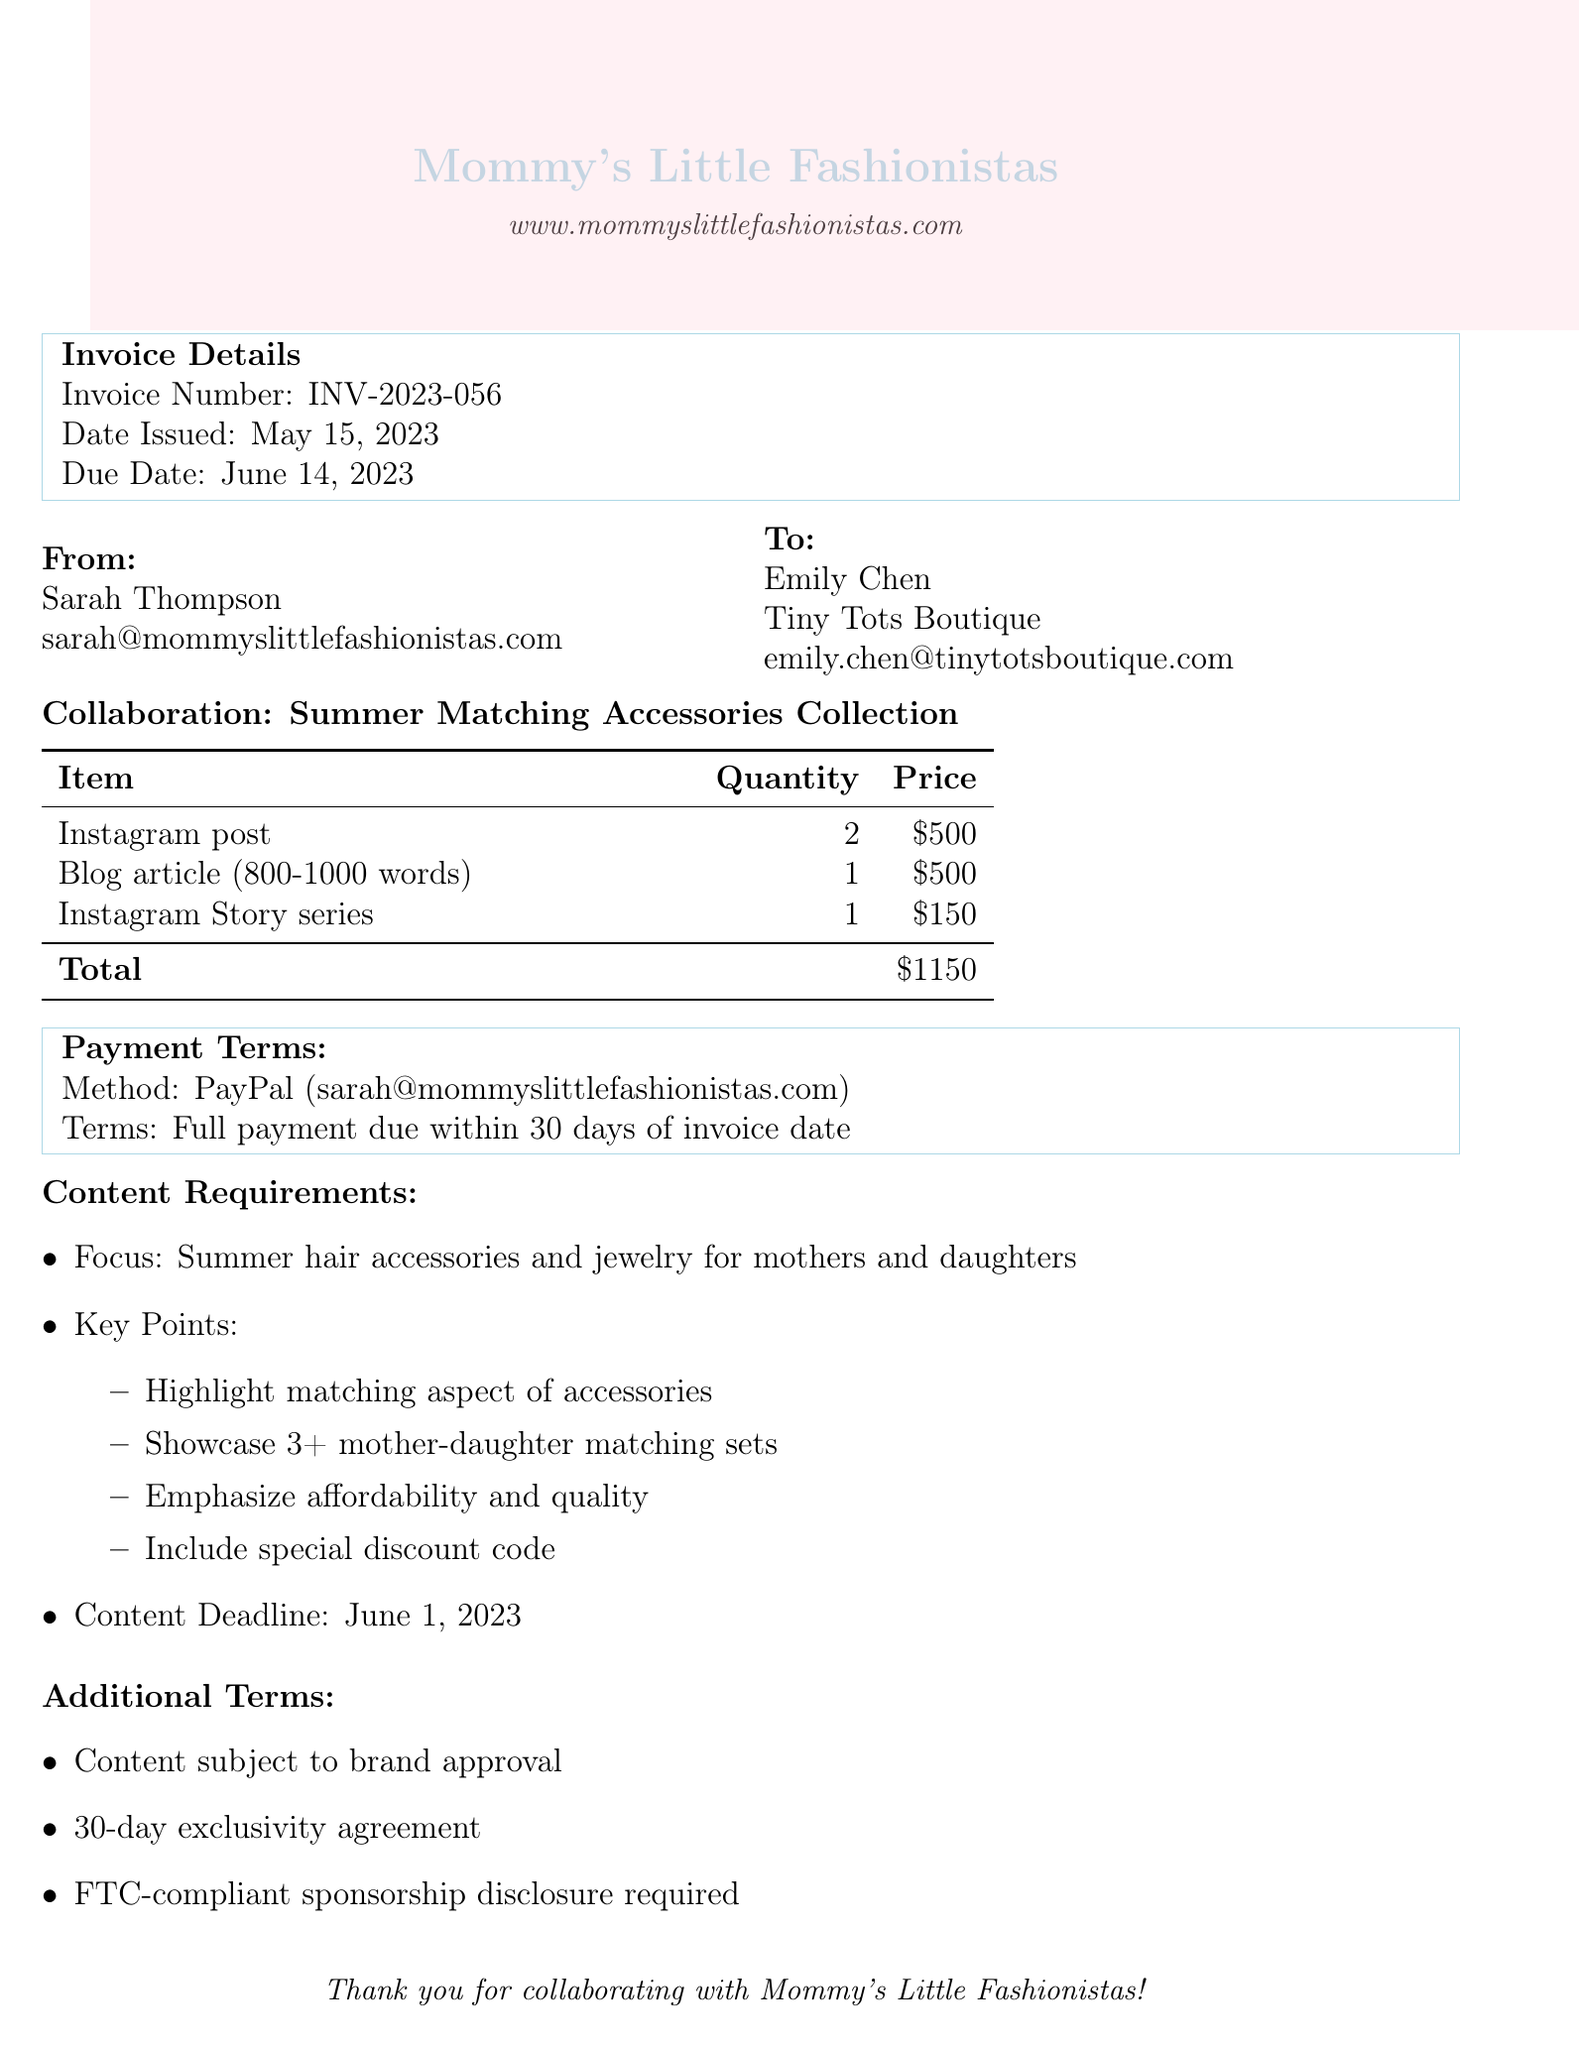What is the invoice number? The invoice number can be found in the invoice details section.
Answer: INV-2023-056 What is the total amount billed? The total amount is listed at the end of the collaboration details section.
Answer: $1150 When is the content deadline? The content deadline is specified in the content requirements section.
Answer: June 1, 2023 What payment method is accepted? The payment method is mentioned in the payment terms section.
Answer: PayPal Who is the contact person for the brand? The contact person for Tiny Tots Boutique is provided in the brand info section.
Answer: Emily Chen What type of content is to be created? The type of content required for the collaboration is detailed in the content requirements section.
Answer: Summer hair accessories and jewelry How many Instagram posts are requested? The quantity of Instagram posts is specified in the deliverables table.
Answer: 2 What is the exclusivity agreement duration? The duration of the exclusivity agreement is stated in the additional terms.
Answer: 30 days What must be included in the blog post according to the key points? The key points section specifies important elements to include in the blog post.
Answer: Special discount code 